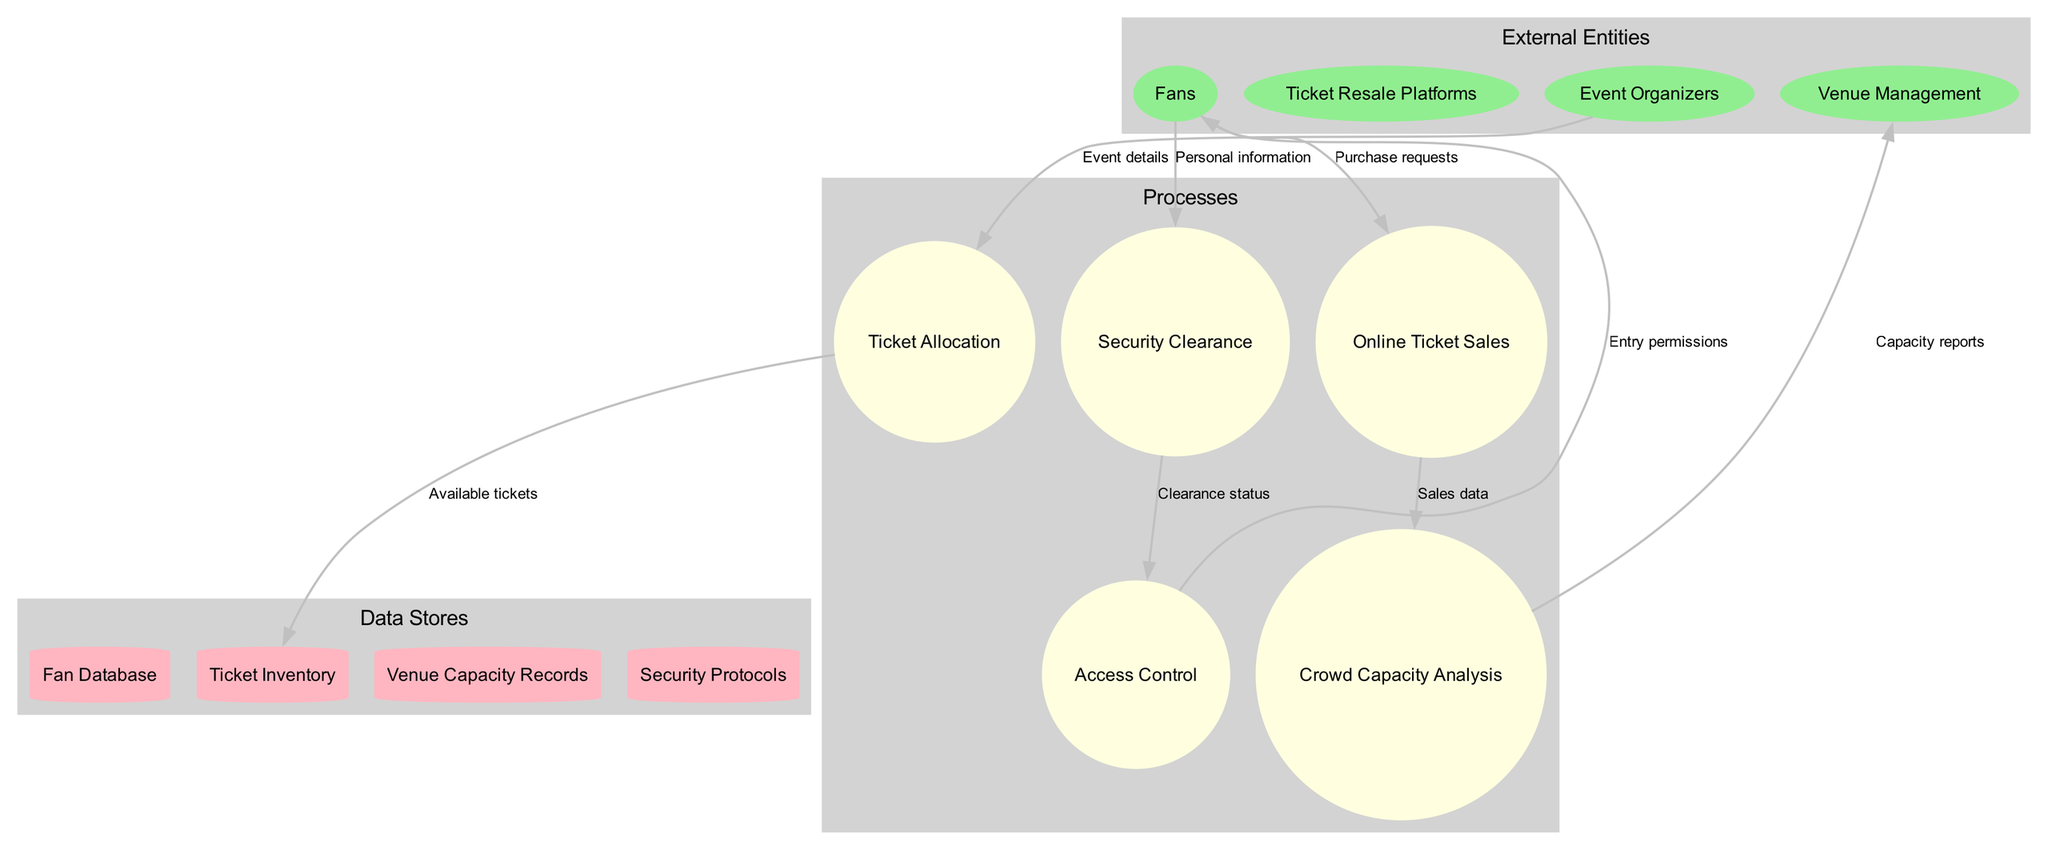What are the external entities involved? The diagram shows four external entities: Fans, Ticket Resale Platforms, Event Organizers, and Venue Management.
Answer: Fans, Ticket Resale Platforms, Event Organizers, Venue Management How many processes are depicted in the diagram? There are five processes shown in the diagram: Ticket Allocation, Online Ticket Sales, Crowd Capacity Analysis, Security Clearance, and Access Control.
Answer: 5 What is the first process that receives data from Event Organizers? The data flow indicates that the first process that receives data from Event Organizers is Ticket Allocation, where event details are provided.
Answer: Ticket Allocation What is the output of the "Crowd Capacity Analysis" process? The Crowd Capacity Analysis process generates capacity reports, which are sent to Venue Management.
Answer: Capacity reports Which external entity provides personal information to the Security Clearance process? According to the diagram, Fans provide personal information to the Security Clearance process.
Answer: Fans How many data flows are illustrated in the diagram? The diagram features a total of eight data flows connecting the external entities, processes, and data stores.
Answer: 8 What is the purpose of the data flow from Security Clearance to Access Control? The data flow between Security Clearance and Access Control conveys the clearance status, which allows for managing entry permissions.
Answer: Clearance status What information is received by Venue Management from the Crowd Capacity Analysis? Venue Management receives capacity reports, which provide insights on crowd management and capacity limits.
Answer: Capacity reports 